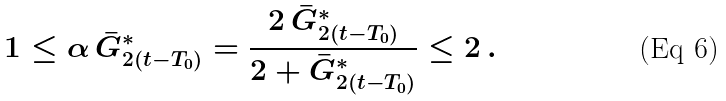<formula> <loc_0><loc_0><loc_500><loc_500>1 \leq \alpha \, \bar { G } ^ { * } _ { 2 ( t - T _ { 0 } ) } = \frac { 2 \, \bar { G } ^ { * } _ { 2 ( t - T _ { 0 } ) } } { 2 + \bar { G } ^ { * } _ { 2 ( t - T _ { 0 } ) } } \leq 2 \, .</formula> 